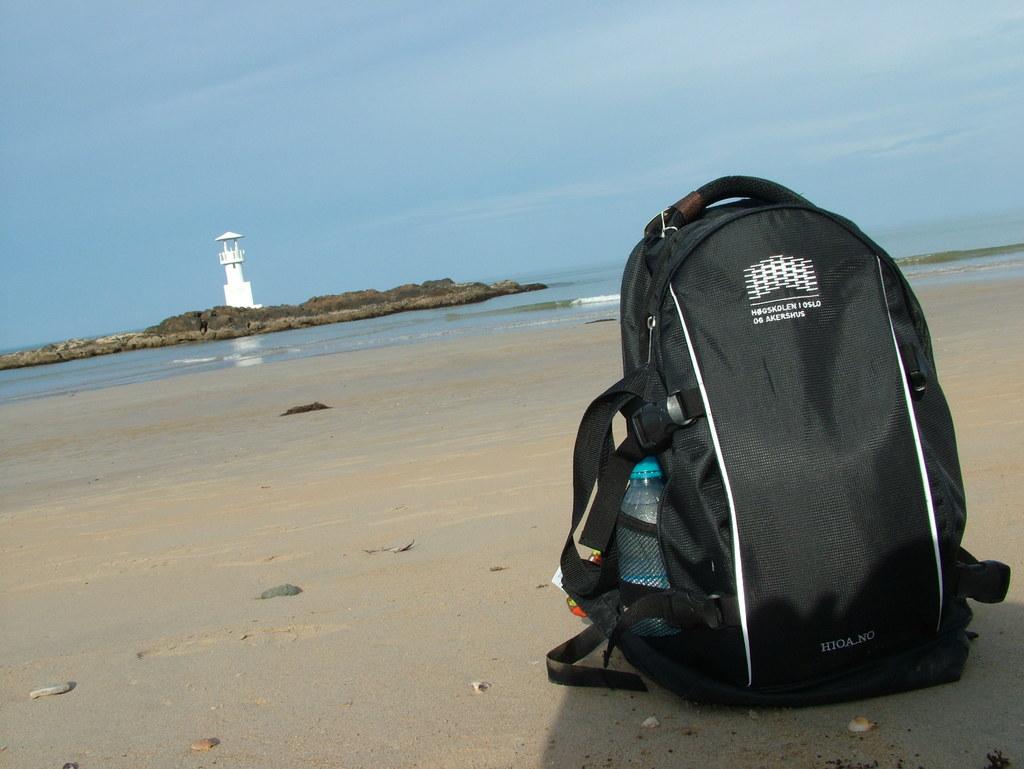What brand is the backpack?
Provide a succinct answer. Hioa no. 